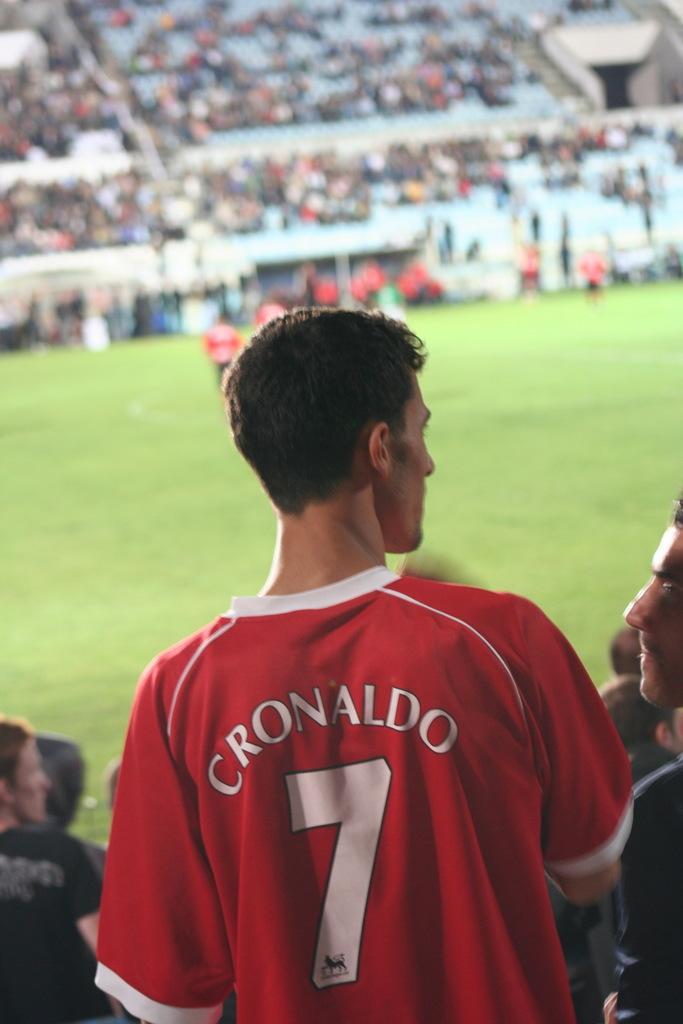<image>
Present a compact description of the photo's key features. A man is wearing a red C Ronaldo jersey with the number 7 on it. 